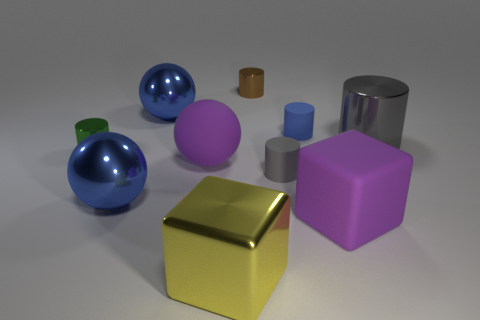Are the objects arranged in any discernible pattern? The objects are not arranged in a specific pattern; they are placed randomly on a flat surface. There is a mix of geometric shapes like spheres, cylinders, and cubes, which create a visually interesting assortment without any apparent order. 